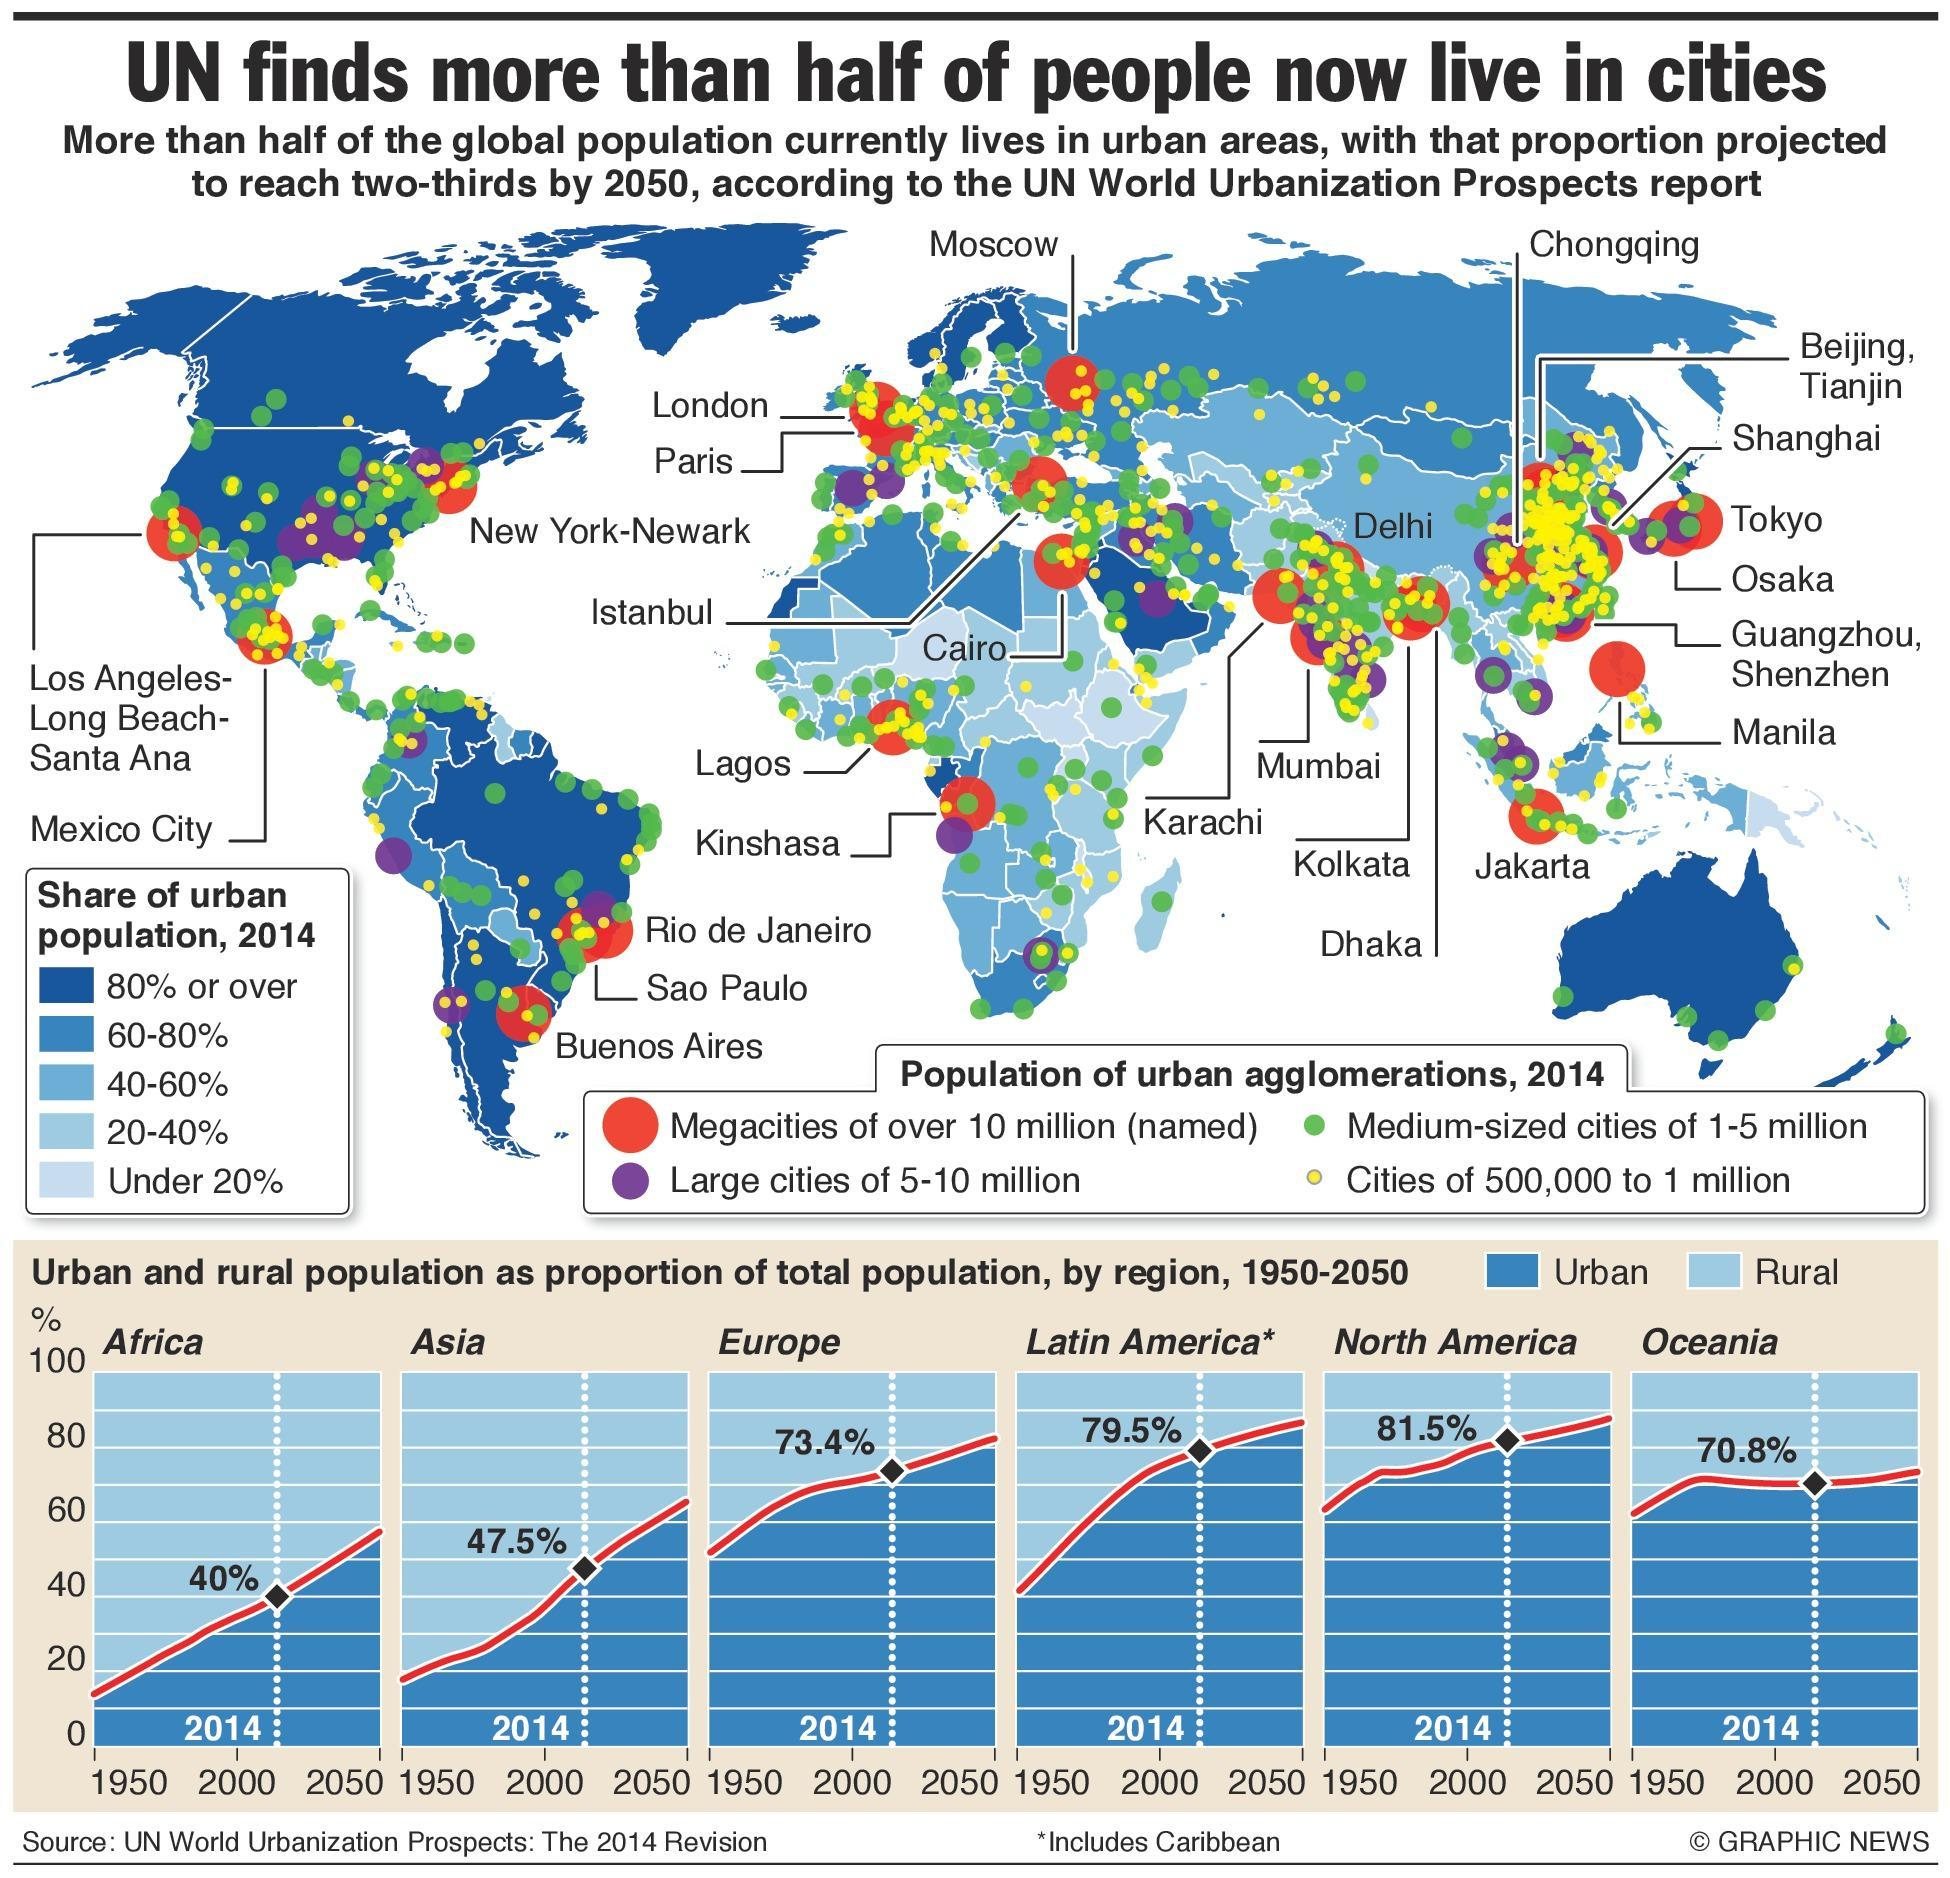What percentage of urban population is predominantly in the USA?
Answer the question with a short phrase. 80% or over What percentage of urban population is predominantly in Australia? 80% or over 